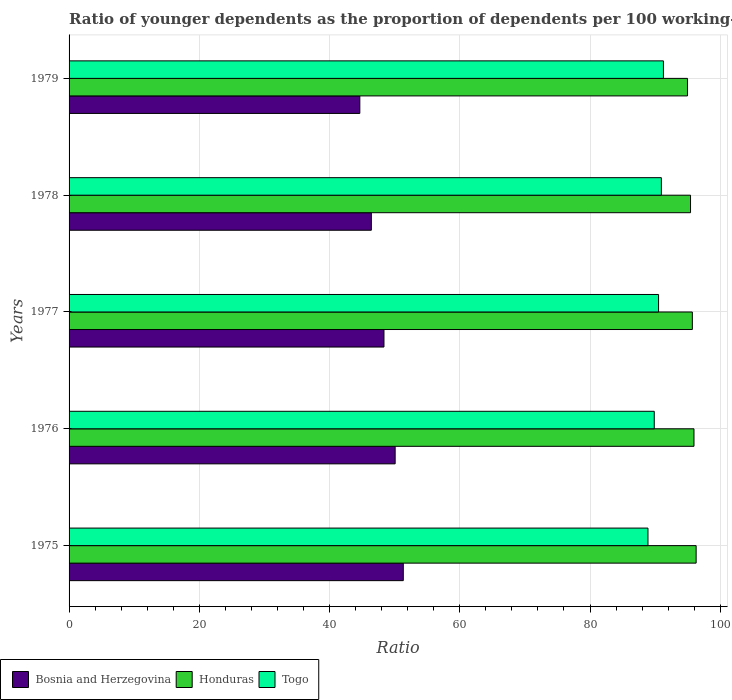How many groups of bars are there?
Provide a short and direct response. 5. Are the number of bars on each tick of the Y-axis equal?
Keep it short and to the point. Yes. What is the label of the 5th group of bars from the top?
Your answer should be very brief. 1975. In how many cases, is the number of bars for a given year not equal to the number of legend labels?
Offer a terse response. 0. What is the age dependency ratio(young) in Bosnia and Herzegovina in 1975?
Give a very brief answer. 51.32. Across all years, what is the maximum age dependency ratio(young) in Honduras?
Keep it short and to the point. 96.29. Across all years, what is the minimum age dependency ratio(young) in Bosnia and Herzegovina?
Give a very brief answer. 44.65. In which year was the age dependency ratio(young) in Bosnia and Herzegovina maximum?
Your answer should be very brief. 1975. In which year was the age dependency ratio(young) in Togo minimum?
Give a very brief answer. 1975. What is the total age dependency ratio(young) in Honduras in the graph?
Ensure brevity in your answer.  478.37. What is the difference between the age dependency ratio(young) in Honduras in 1977 and that in 1978?
Provide a succinct answer. 0.28. What is the difference between the age dependency ratio(young) in Bosnia and Herzegovina in 1979 and the age dependency ratio(young) in Honduras in 1978?
Your response must be concise. -50.78. What is the average age dependency ratio(young) in Bosnia and Herzegovina per year?
Your response must be concise. 48.16. In the year 1976, what is the difference between the age dependency ratio(young) in Togo and age dependency ratio(young) in Honduras?
Your answer should be very brief. -6.1. What is the ratio of the age dependency ratio(young) in Honduras in 1975 to that in 1977?
Your answer should be very brief. 1.01. What is the difference between the highest and the second highest age dependency ratio(young) in Honduras?
Provide a succinct answer. 0.33. What is the difference between the highest and the lowest age dependency ratio(young) in Togo?
Keep it short and to the point. 2.37. What does the 3rd bar from the top in 1977 represents?
Your answer should be very brief. Bosnia and Herzegovina. What does the 1st bar from the bottom in 1976 represents?
Make the answer very short. Bosnia and Herzegovina. Are all the bars in the graph horizontal?
Your response must be concise. Yes. How many years are there in the graph?
Ensure brevity in your answer.  5. What is the difference between two consecutive major ticks on the X-axis?
Your answer should be compact. 20. Does the graph contain any zero values?
Your answer should be very brief. No. Does the graph contain grids?
Offer a terse response. Yes. How are the legend labels stacked?
Ensure brevity in your answer.  Horizontal. What is the title of the graph?
Keep it short and to the point. Ratio of younger dependents as the proportion of dependents per 100 working-age population. What is the label or title of the X-axis?
Your answer should be very brief. Ratio. What is the label or title of the Y-axis?
Make the answer very short. Years. What is the Ratio of Bosnia and Herzegovina in 1975?
Make the answer very short. 51.32. What is the Ratio of Honduras in 1975?
Offer a terse response. 96.29. What is the Ratio in Togo in 1975?
Ensure brevity in your answer.  88.9. What is the Ratio in Bosnia and Herzegovina in 1976?
Offer a very short reply. 50.07. What is the Ratio of Honduras in 1976?
Give a very brief answer. 95.96. What is the Ratio of Togo in 1976?
Give a very brief answer. 89.86. What is the Ratio in Bosnia and Herzegovina in 1977?
Provide a succinct answer. 48.36. What is the Ratio in Honduras in 1977?
Offer a very short reply. 95.71. What is the Ratio of Togo in 1977?
Offer a very short reply. 90.52. What is the Ratio of Bosnia and Herzegovina in 1978?
Your response must be concise. 46.42. What is the Ratio of Honduras in 1978?
Offer a terse response. 95.43. What is the Ratio in Togo in 1978?
Ensure brevity in your answer.  90.95. What is the Ratio of Bosnia and Herzegovina in 1979?
Ensure brevity in your answer.  44.65. What is the Ratio of Honduras in 1979?
Make the answer very short. 94.96. What is the Ratio of Togo in 1979?
Provide a short and direct response. 91.27. Across all years, what is the maximum Ratio in Bosnia and Herzegovina?
Offer a very short reply. 51.32. Across all years, what is the maximum Ratio in Honduras?
Provide a succinct answer. 96.29. Across all years, what is the maximum Ratio in Togo?
Offer a terse response. 91.27. Across all years, what is the minimum Ratio in Bosnia and Herzegovina?
Offer a very short reply. 44.65. Across all years, what is the minimum Ratio of Honduras?
Your response must be concise. 94.96. Across all years, what is the minimum Ratio of Togo?
Offer a terse response. 88.9. What is the total Ratio of Bosnia and Herzegovina in the graph?
Ensure brevity in your answer.  240.82. What is the total Ratio of Honduras in the graph?
Give a very brief answer. 478.37. What is the total Ratio of Togo in the graph?
Your response must be concise. 451.51. What is the difference between the Ratio of Bosnia and Herzegovina in 1975 and that in 1976?
Your answer should be compact. 1.25. What is the difference between the Ratio in Honduras in 1975 and that in 1976?
Keep it short and to the point. 0.33. What is the difference between the Ratio of Togo in 1975 and that in 1976?
Keep it short and to the point. -0.96. What is the difference between the Ratio of Bosnia and Herzegovina in 1975 and that in 1977?
Make the answer very short. 2.97. What is the difference between the Ratio of Honduras in 1975 and that in 1977?
Provide a succinct answer. 0.58. What is the difference between the Ratio of Togo in 1975 and that in 1977?
Your response must be concise. -1.63. What is the difference between the Ratio of Bosnia and Herzegovina in 1975 and that in 1978?
Provide a short and direct response. 4.91. What is the difference between the Ratio of Honduras in 1975 and that in 1978?
Your answer should be very brief. 0.86. What is the difference between the Ratio in Togo in 1975 and that in 1978?
Your answer should be very brief. -2.06. What is the difference between the Ratio in Bosnia and Herzegovina in 1975 and that in 1979?
Provide a succinct answer. 6.67. What is the difference between the Ratio in Honduras in 1975 and that in 1979?
Provide a succinct answer. 1.33. What is the difference between the Ratio in Togo in 1975 and that in 1979?
Your answer should be very brief. -2.37. What is the difference between the Ratio in Bosnia and Herzegovina in 1976 and that in 1977?
Provide a short and direct response. 1.72. What is the difference between the Ratio of Honduras in 1976 and that in 1977?
Provide a succinct answer. 0.25. What is the difference between the Ratio of Togo in 1976 and that in 1977?
Offer a terse response. -0.66. What is the difference between the Ratio of Bosnia and Herzegovina in 1976 and that in 1978?
Offer a very short reply. 3.66. What is the difference between the Ratio in Honduras in 1976 and that in 1978?
Your answer should be very brief. 0.53. What is the difference between the Ratio in Togo in 1976 and that in 1978?
Your answer should be very brief. -1.09. What is the difference between the Ratio of Bosnia and Herzegovina in 1976 and that in 1979?
Offer a very short reply. 5.42. What is the difference between the Ratio in Honduras in 1976 and that in 1979?
Provide a succinct answer. 1. What is the difference between the Ratio in Togo in 1976 and that in 1979?
Provide a short and direct response. -1.41. What is the difference between the Ratio in Bosnia and Herzegovina in 1977 and that in 1978?
Your answer should be compact. 1.94. What is the difference between the Ratio in Honduras in 1977 and that in 1978?
Keep it short and to the point. 0.28. What is the difference between the Ratio in Togo in 1977 and that in 1978?
Provide a short and direct response. -0.43. What is the difference between the Ratio of Bosnia and Herzegovina in 1977 and that in 1979?
Your answer should be compact. 3.71. What is the difference between the Ratio in Honduras in 1977 and that in 1979?
Give a very brief answer. 0.75. What is the difference between the Ratio of Togo in 1977 and that in 1979?
Give a very brief answer. -0.75. What is the difference between the Ratio of Bosnia and Herzegovina in 1978 and that in 1979?
Give a very brief answer. 1.77. What is the difference between the Ratio of Honduras in 1978 and that in 1979?
Your answer should be very brief. 0.47. What is the difference between the Ratio of Togo in 1978 and that in 1979?
Your answer should be very brief. -0.32. What is the difference between the Ratio in Bosnia and Herzegovina in 1975 and the Ratio in Honduras in 1976?
Keep it short and to the point. -44.64. What is the difference between the Ratio of Bosnia and Herzegovina in 1975 and the Ratio of Togo in 1976?
Make the answer very short. -38.54. What is the difference between the Ratio in Honduras in 1975 and the Ratio in Togo in 1976?
Provide a succinct answer. 6.43. What is the difference between the Ratio in Bosnia and Herzegovina in 1975 and the Ratio in Honduras in 1977?
Provide a short and direct response. -44.39. What is the difference between the Ratio of Bosnia and Herzegovina in 1975 and the Ratio of Togo in 1977?
Offer a very short reply. -39.2. What is the difference between the Ratio in Honduras in 1975 and the Ratio in Togo in 1977?
Give a very brief answer. 5.77. What is the difference between the Ratio of Bosnia and Herzegovina in 1975 and the Ratio of Honduras in 1978?
Offer a terse response. -44.11. What is the difference between the Ratio of Bosnia and Herzegovina in 1975 and the Ratio of Togo in 1978?
Offer a very short reply. -39.63. What is the difference between the Ratio of Honduras in 1975 and the Ratio of Togo in 1978?
Provide a succinct answer. 5.34. What is the difference between the Ratio in Bosnia and Herzegovina in 1975 and the Ratio in Honduras in 1979?
Offer a terse response. -43.64. What is the difference between the Ratio of Bosnia and Herzegovina in 1975 and the Ratio of Togo in 1979?
Your answer should be very brief. -39.95. What is the difference between the Ratio in Honduras in 1975 and the Ratio in Togo in 1979?
Make the answer very short. 5.02. What is the difference between the Ratio of Bosnia and Herzegovina in 1976 and the Ratio of Honduras in 1977?
Your response must be concise. -45.64. What is the difference between the Ratio in Bosnia and Herzegovina in 1976 and the Ratio in Togo in 1977?
Offer a terse response. -40.45. What is the difference between the Ratio of Honduras in 1976 and the Ratio of Togo in 1977?
Ensure brevity in your answer.  5.44. What is the difference between the Ratio in Bosnia and Herzegovina in 1976 and the Ratio in Honduras in 1978?
Ensure brevity in your answer.  -45.36. What is the difference between the Ratio of Bosnia and Herzegovina in 1976 and the Ratio of Togo in 1978?
Your answer should be very brief. -40.88. What is the difference between the Ratio of Honduras in 1976 and the Ratio of Togo in 1978?
Provide a succinct answer. 5.01. What is the difference between the Ratio in Bosnia and Herzegovina in 1976 and the Ratio in Honduras in 1979?
Offer a terse response. -44.89. What is the difference between the Ratio in Bosnia and Herzegovina in 1976 and the Ratio in Togo in 1979?
Provide a short and direct response. -41.2. What is the difference between the Ratio of Honduras in 1976 and the Ratio of Togo in 1979?
Your answer should be compact. 4.69. What is the difference between the Ratio in Bosnia and Herzegovina in 1977 and the Ratio in Honduras in 1978?
Provide a succinct answer. -47.08. What is the difference between the Ratio of Bosnia and Herzegovina in 1977 and the Ratio of Togo in 1978?
Your answer should be very brief. -42.6. What is the difference between the Ratio in Honduras in 1977 and the Ratio in Togo in 1978?
Your answer should be very brief. 4.76. What is the difference between the Ratio of Bosnia and Herzegovina in 1977 and the Ratio of Honduras in 1979?
Give a very brief answer. -46.61. What is the difference between the Ratio in Bosnia and Herzegovina in 1977 and the Ratio in Togo in 1979?
Provide a succinct answer. -42.91. What is the difference between the Ratio of Honduras in 1977 and the Ratio of Togo in 1979?
Provide a short and direct response. 4.44. What is the difference between the Ratio in Bosnia and Herzegovina in 1978 and the Ratio in Honduras in 1979?
Your answer should be very brief. -48.55. What is the difference between the Ratio of Bosnia and Herzegovina in 1978 and the Ratio of Togo in 1979?
Give a very brief answer. -44.85. What is the difference between the Ratio of Honduras in 1978 and the Ratio of Togo in 1979?
Give a very brief answer. 4.16. What is the average Ratio in Bosnia and Herzegovina per year?
Offer a terse response. 48.16. What is the average Ratio of Honduras per year?
Offer a very short reply. 95.67. What is the average Ratio in Togo per year?
Your answer should be compact. 90.3. In the year 1975, what is the difference between the Ratio of Bosnia and Herzegovina and Ratio of Honduras?
Offer a terse response. -44.97. In the year 1975, what is the difference between the Ratio of Bosnia and Herzegovina and Ratio of Togo?
Your response must be concise. -37.57. In the year 1975, what is the difference between the Ratio in Honduras and Ratio in Togo?
Your answer should be very brief. 7.4. In the year 1976, what is the difference between the Ratio of Bosnia and Herzegovina and Ratio of Honduras?
Provide a succinct answer. -45.89. In the year 1976, what is the difference between the Ratio of Bosnia and Herzegovina and Ratio of Togo?
Make the answer very short. -39.79. In the year 1976, what is the difference between the Ratio of Honduras and Ratio of Togo?
Your answer should be very brief. 6.1. In the year 1977, what is the difference between the Ratio of Bosnia and Herzegovina and Ratio of Honduras?
Offer a very short reply. -47.36. In the year 1977, what is the difference between the Ratio of Bosnia and Herzegovina and Ratio of Togo?
Give a very brief answer. -42.17. In the year 1977, what is the difference between the Ratio in Honduras and Ratio in Togo?
Make the answer very short. 5.19. In the year 1978, what is the difference between the Ratio of Bosnia and Herzegovina and Ratio of Honduras?
Your answer should be very brief. -49.01. In the year 1978, what is the difference between the Ratio of Bosnia and Herzegovina and Ratio of Togo?
Offer a very short reply. -44.54. In the year 1978, what is the difference between the Ratio of Honduras and Ratio of Togo?
Provide a short and direct response. 4.48. In the year 1979, what is the difference between the Ratio of Bosnia and Herzegovina and Ratio of Honduras?
Provide a short and direct response. -50.31. In the year 1979, what is the difference between the Ratio of Bosnia and Herzegovina and Ratio of Togo?
Your response must be concise. -46.62. In the year 1979, what is the difference between the Ratio of Honduras and Ratio of Togo?
Give a very brief answer. 3.69. What is the ratio of the Ratio in Bosnia and Herzegovina in 1975 to that in 1976?
Offer a very short reply. 1.02. What is the ratio of the Ratio of Togo in 1975 to that in 1976?
Your answer should be compact. 0.99. What is the ratio of the Ratio in Bosnia and Herzegovina in 1975 to that in 1977?
Provide a succinct answer. 1.06. What is the ratio of the Ratio of Bosnia and Herzegovina in 1975 to that in 1978?
Offer a very short reply. 1.11. What is the ratio of the Ratio in Togo in 1975 to that in 1978?
Provide a succinct answer. 0.98. What is the ratio of the Ratio of Bosnia and Herzegovina in 1975 to that in 1979?
Offer a terse response. 1.15. What is the ratio of the Ratio in Honduras in 1975 to that in 1979?
Your answer should be compact. 1.01. What is the ratio of the Ratio in Togo in 1975 to that in 1979?
Give a very brief answer. 0.97. What is the ratio of the Ratio in Bosnia and Herzegovina in 1976 to that in 1977?
Your response must be concise. 1.04. What is the ratio of the Ratio of Togo in 1976 to that in 1977?
Your answer should be very brief. 0.99. What is the ratio of the Ratio of Bosnia and Herzegovina in 1976 to that in 1978?
Offer a very short reply. 1.08. What is the ratio of the Ratio of Honduras in 1976 to that in 1978?
Offer a terse response. 1.01. What is the ratio of the Ratio of Togo in 1976 to that in 1978?
Ensure brevity in your answer.  0.99. What is the ratio of the Ratio in Bosnia and Herzegovina in 1976 to that in 1979?
Provide a succinct answer. 1.12. What is the ratio of the Ratio in Honduras in 1976 to that in 1979?
Offer a very short reply. 1.01. What is the ratio of the Ratio in Togo in 1976 to that in 1979?
Give a very brief answer. 0.98. What is the ratio of the Ratio in Bosnia and Herzegovina in 1977 to that in 1978?
Provide a short and direct response. 1.04. What is the ratio of the Ratio of Honduras in 1977 to that in 1978?
Your response must be concise. 1. What is the ratio of the Ratio of Togo in 1977 to that in 1978?
Offer a terse response. 1. What is the ratio of the Ratio in Bosnia and Herzegovina in 1977 to that in 1979?
Your response must be concise. 1.08. What is the ratio of the Ratio in Honduras in 1977 to that in 1979?
Provide a short and direct response. 1.01. What is the ratio of the Ratio of Bosnia and Herzegovina in 1978 to that in 1979?
Provide a short and direct response. 1.04. What is the ratio of the Ratio of Honduras in 1978 to that in 1979?
Keep it short and to the point. 1. What is the ratio of the Ratio in Togo in 1978 to that in 1979?
Keep it short and to the point. 1. What is the difference between the highest and the second highest Ratio of Bosnia and Herzegovina?
Provide a succinct answer. 1.25. What is the difference between the highest and the second highest Ratio in Honduras?
Keep it short and to the point. 0.33. What is the difference between the highest and the second highest Ratio of Togo?
Provide a short and direct response. 0.32. What is the difference between the highest and the lowest Ratio in Bosnia and Herzegovina?
Your response must be concise. 6.67. What is the difference between the highest and the lowest Ratio of Honduras?
Provide a short and direct response. 1.33. What is the difference between the highest and the lowest Ratio of Togo?
Ensure brevity in your answer.  2.37. 